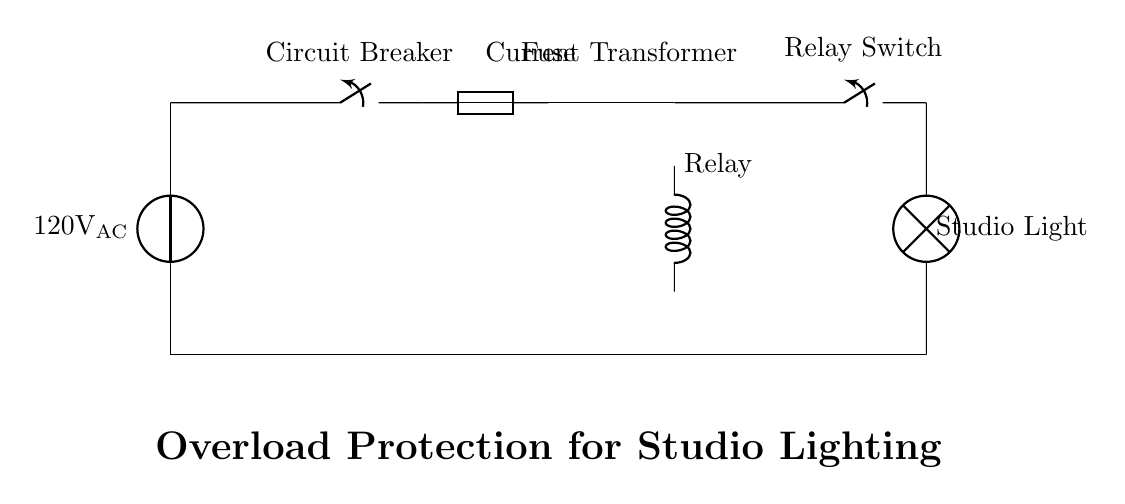What is the voltage of this circuit? The voltage is 120 volts, indicated by the voltage source labeled "120V AC" at the top of the circuit diagram.
Answer: 120 volts What component is used for initial protection in this circuit? The initial protection component is the circuit breaker, which is represented at the beginning of the power supply in the circuit diagram.
Answer: Circuit breaker How many protection devices are in this circuit? There are three protection devices: a circuit breaker, a fuse, and a relay. These are all clearly labeled in the diagram as separate components.
Answer: Three What is the function of the current transformer in this circuit? The current transformer is used to monitor the current flowing through the circuit; it detects overload conditions and helps operate the relay when necessary.
Answer: Monitor current Which component allows manual control of the studio lights? The component that allows manual control is the relay switch, which is also labeled in the circuit. It connects or disconnects the studio light from the circuit.
Answer: Relay switch How does the relay operate in response to an overload? The relay operates by using the current transformer to detect an overload condition, which triggers the relay coil; this action causes the relay switch to open and disconnect the studio light from the power source.
Answer: Opens relay switch What is the purpose of the fuse in this protection circuit? The fuse serves to add an additional layer of protection by melting and breaking the circuit if the current exceeds a certain limit, preventing damage to the components.
Answer: Break circuit 